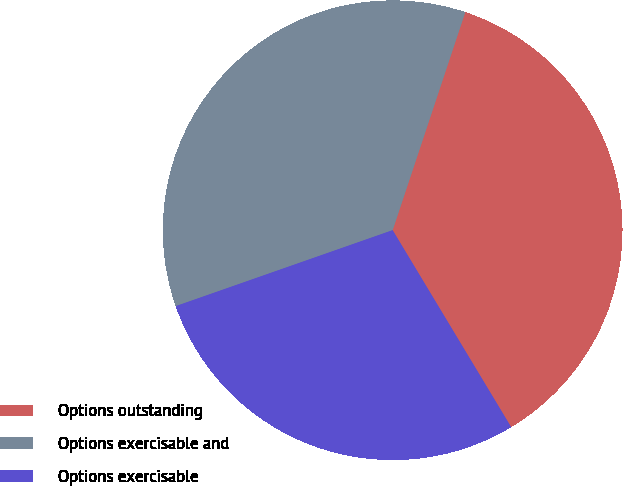Convert chart. <chart><loc_0><loc_0><loc_500><loc_500><pie_chart><fcel>Options outstanding<fcel>Options exercisable and<fcel>Options exercisable<nl><fcel>36.26%<fcel>35.48%<fcel>28.26%<nl></chart> 